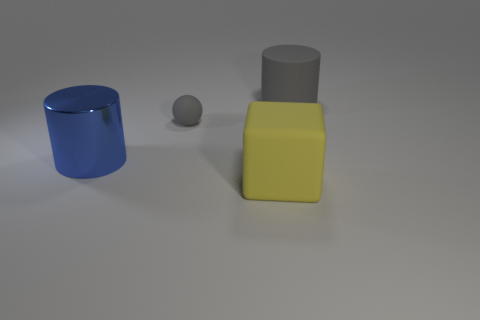How many gray objects are either matte balls or metallic things?
Keep it short and to the point. 1. There is a big rubber thing that is behind the gray matte object to the left of the large matte thing right of the yellow rubber object; what is its shape?
Give a very brief answer. Cylinder. There is a matte cylinder that is the same size as the blue metal cylinder; what color is it?
Give a very brief answer. Gray. What number of other yellow rubber things are the same shape as the large yellow thing?
Keep it short and to the point. 0. There is a rubber sphere; does it have the same size as the cylinder in front of the gray cylinder?
Make the answer very short. No. There is a big object that is on the right side of the big object that is in front of the big metal cylinder; what shape is it?
Make the answer very short. Cylinder. Is the number of blue cylinders that are on the right side of the big gray cylinder less than the number of blue objects?
Give a very brief answer. Yes. The rubber thing that is the same color as the matte cylinder is what shape?
Your answer should be very brief. Sphere. How many gray spheres are the same size as the yellow block?
Your response must be concise. 0. There is a large matte thing behind the large blue metallic cylinder; what is its shape?
Your response must be concise. Cylinder. 